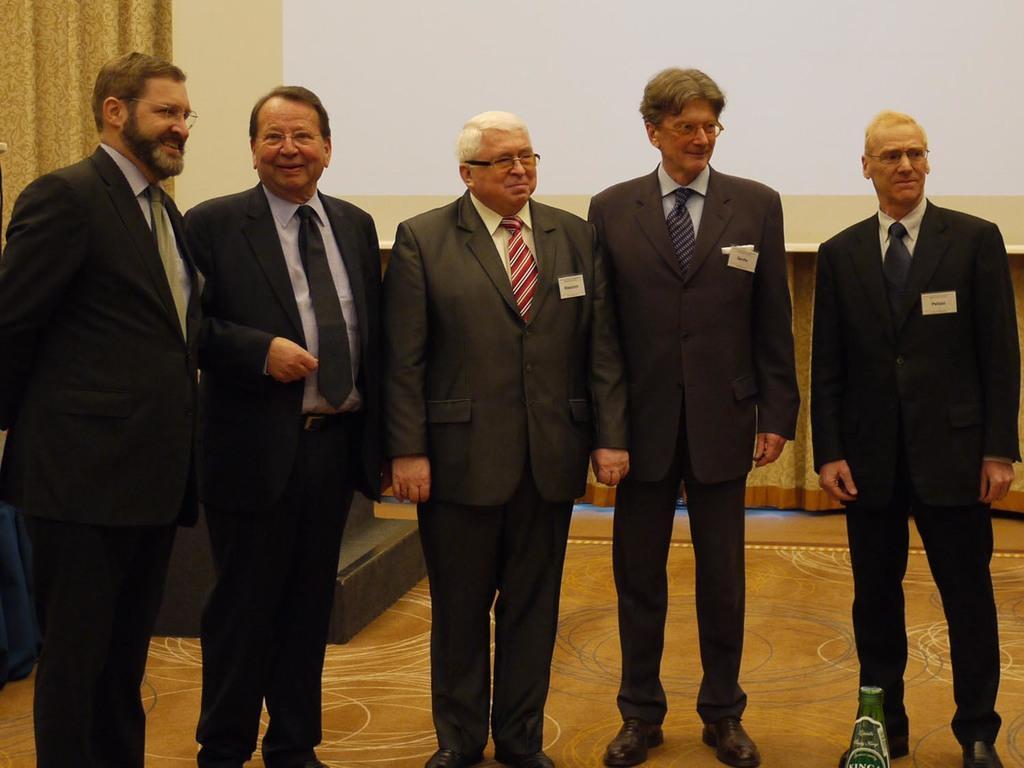How would you summarize this image in a sentence or two? In this picture there is an old man who is wearing spectacle, suit, trouser and shoe. He is standing near to the man who is wearing spectacles, suit and shoe. On the right there is a man who is standing on the carpet. On the left there is a man who is wearing spectacle, suit and trouser. Beside him there is another man. In the back I can see the clothes and projector screen. 